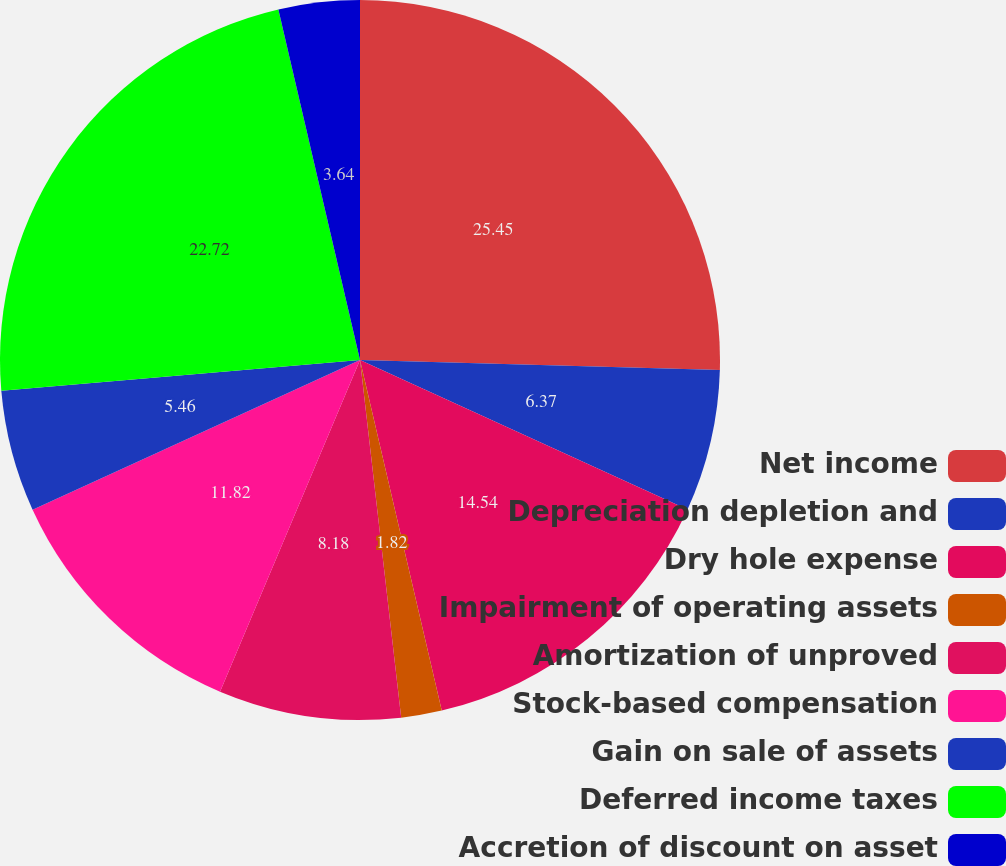<chart> <loc_0><loc_0><loc_500><loc_500><pie_chart><fcel>Net income<fcel>Depreciation depletion and<fcel>Dry hole expense<fcel>Impairment of operating assets<fcel>Amortization of unproved<fcel>Stock-based compensation<fcel>Gain on sale of assets<fcel>Deferred income taxes<fcel>Accretion of discount on asset<nl><fcel>25.44%<fcel>6.37%<fcel>14.54%<fcel>1.82%<fcel>8.18%<fcel>11.82%<fcel>5.46%<fcel>22.72%<fcel>3.64%<nl></chart> 